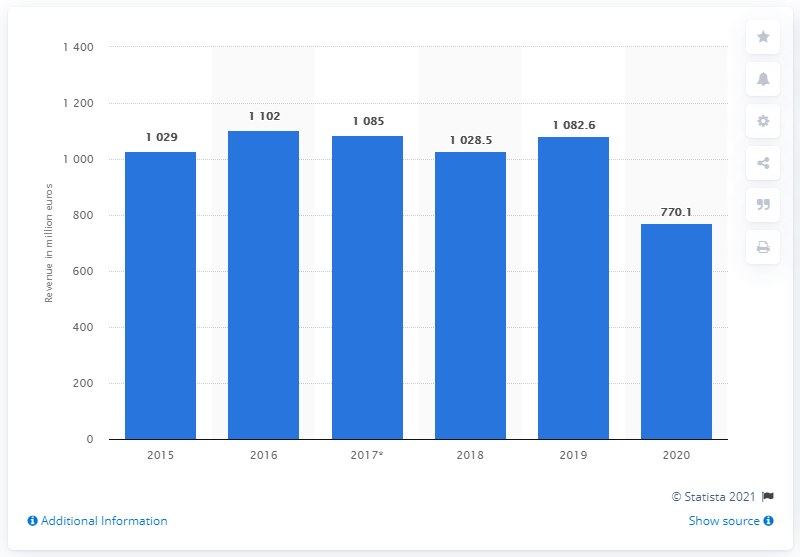Outline some significant characteristics in this image. Barco's revenue in 2020 was 770.1 million dollars. Barco's revenue in 2019 was 1082.6 million. 